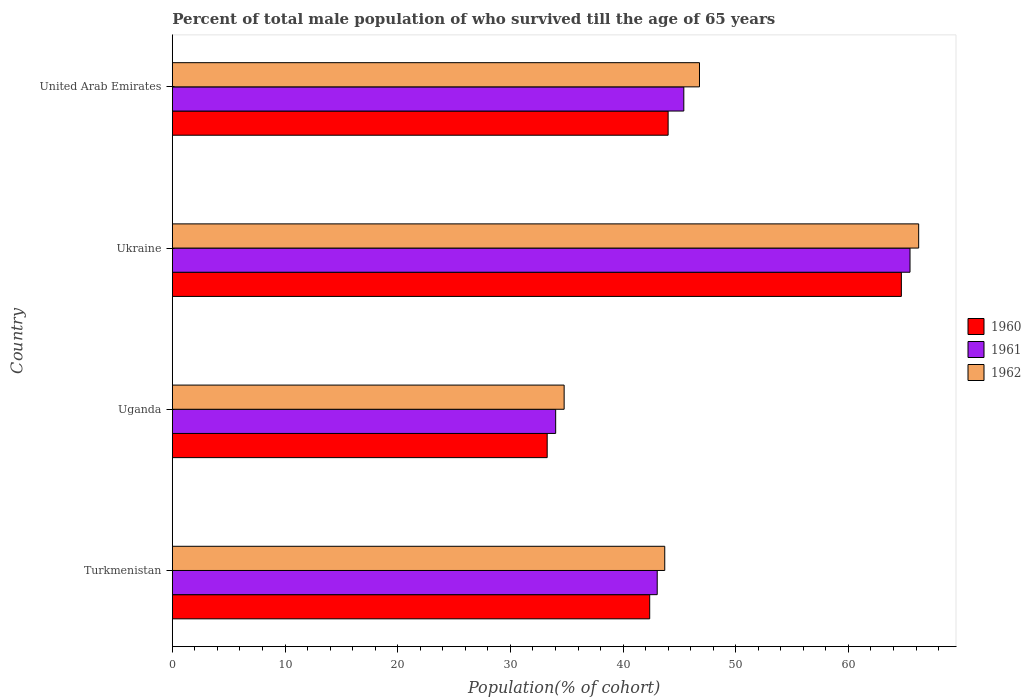How many bars are there on the 4th tick from the top?
Your response must be concise. 3. How many bars are there on the 3rd tick from the bottom?
Give a very brief answer. 3. What is the label of the 4th group of bars from the top?
Offer a very short reply. Turkmenistan. What is the percentage of total male population who survived till the age of 65 years in 1960 in Uganda?
Ensure brevity in your answer.  33.27. Across all countries, what is the maximum percentage of total male population who survived till the age of 65 years in 1960?
Make the answer very short. 64.7. Across all countries, what is the minimum percentage of total male population who survived till the age of 65 years in 1962?
Give a very brief answer. 34.77. In which country was the percentage of total male population who survived till the age of 65 years in 1960 maximum?
Ensure brevity in your answer.  Ukraine. In which country was the percentage of total male population who survived till the age of 65 years in 1961 minimum?
Your response must be concise. Uganda. What is the total percentage of total male population who survived till the age of 65 years in 1961 in the graph?
Offer a terse response. 187.9. What is the difference between the percentage of total male population who survived till the age of 65 years in 1962 in Uganda and that in Ukraine?
Your answer should be compact. -31.46. What is the difference between the percentage of total male population who survived till the age of 65 years in 1962 in Uganda and the percentage of total male population who survived till the age of 65 years in 1961 in United Arab Emirates?
Ensure brevity in your answer.  -10.62. What is the average percentage of total male population who survived till the age of 65 years in 1961 per country?
Provide a short and direct response. 46.98. What is the difference between the percentage of total male population who survived till the age of 65 years in 1960 and percentage of total male population who survived till the age of 65 years in 1961 in Ukraine?
Ensure brevity in your answer.  -0.77. What is the ratio of the percentage of total male population who survived till the age of 65 years in 1960 in Turkmenistan to that in United Arab Emirates?
Your response must be concise. 0.96. Is the percentage of total male population who survived till the age of 65 years in 1962 in Turkmenistan less than that in Ukraine?
Your answer should be very brief. Yes. What is the difference between the highest and the second highest percentage of total male population who survived till the age of 65 years in 1962?
Keep it short and to the point. 19.45. What is the difference between the highest and the lowest percentage of total male population who survived till the age of 65 years in 1962?
Offer a very short reply. 31.46. What does the 2nd bar from the top in United Arab Emirates represents?
Give a very brief answer. 1961. Is it the case that in every country, the sum of the percentage of total male population who survived till the age of 65 years in 1962 and percentage of total male population who survived till the age of 65 years in 1961 is greater than the percentage of total male population who survived till the age of 65 years in 1960?
Make the answer very short. Yes. How many bars are there?
Offer a terse response. 12. Are the values on the major ticks of X-axis written in scientific E-notation?
Your response must be concise. No. Where does the legend appear in the graph?
Provide a short and direct response. Center right. What is the title of the graph?
Make the answer very short. Percent of total male population of who survived till the age of 65 years. What is the label or title of the X-axis?
Keep it short and to the point. Population(% of cohort). What is the Population(% of cohort) of 1960 in Turkmenistan?
Provide a short and direct response. 42.36. What is the Population(% of cohort) in 1961 in Turkmenistan?
Your response must be concise. 43.03. What is the Population(% of cohort) in 1962 in Turkmenistan?
Provide a succinct answer. 43.7. What is the Population(% of cohort) of 1960 in Uganda?
Keep it short and to the point. 33.27. What is the Population(% of cohort) in 1961 in Uganda?
Your answer should be compact. 34.02. What is the Population(% of cohort) of 1962 in Uganda?
Your answer should be very brief. 34.77. What is the Population(% of cohort) in 1960 in Ukraine?
Your answer should be very brief. 64.7. What is the Population(% of cohort) in 1961 in Ukraine?
Give a very brief answer. 65.46. What is the Population(% of cohort) in 1962 in Ukraine?
Keep it short and to the point. 66.23. What is the Population(% of cohort) of 1960 in United Arab Emirates?
Offer a very short reply. 44. What is the Population(% of cohort) in 1961 in United Arab Emirates?
Ensure brevity in your answer.  45.39. What is the Population(% of cohort) of 1962 in United Arab Emirates?
Keep it short and to the point. 46.78. Across all countries, what is the maximum Population(% of cohort) in 1960?
Ensure brevity in your answer.  64.7. Across all countries, what is the maximum Population(% of cohort) in 1961?
Provide a succinct answer. 65.46. Across all countries, what is the maximum Population(% of cohort) in 1962?
Provide a short and direct response. 66.23. Across all countries, what is the minimum Population(% of cohort) in 1960?
Give a very brief answer. 33.27. Across all countries, what is the minimum Population(% of cohort) of 1961?
Offer a terse response. 34.02. Across all countries, what is the minimum Population(% of cohort) in 1962?
Offer a very short reply. 34.77. What is the total Population(% of cohort) of 1960 in the graph?
Ensure brevity in your answer.  184.32. What is the total Population(% of cohort) in 1961 in the graph?
Provide a succinct answer. 187.9. What is the total Population(% of cohort) in 1962 in the graph?
Ensure brevity in your answer.  191.48. What is the difference between the Population(% of cohort) of 1960 in Turkmenistan and that in Uganda?
Make the answer very short. 9.1. What is the difference between the Population(% of cohort) of 1961 in Turkmenistan and that in Uganda?
Provide a short and direct response. 9.01. What is the difference between the Population(% of cohort) of 1962 in Turkmenistan and that in Uganda?
Keep it short and to the point. 8.93. What is the difference between the Population(% of cohort) in 1960 in Turkmenistan and that in Ukraine?
Keep it short and to the point. -22.33. What is the difference between the Population(% of cohort) in 1961 in Turkmenistan and that in Ukraine?
Your answer should be very brief. -22.43. What is the difference between the Population(% of cohort) in 1962 in Turkmenistan and that in Ukraine?
Your response must be concise. -22.54. What is the difference between the Population(% of cohort) of 1960 in Turkmenistan and that in United Arab Emirates?
Offer a very short reply. -1.64. What is the difference between the Population(% of cohort) in 1961 in Turkmenistan and that in United Arab Emirates?
Ensure brevity in your answer.  -2.36. What is the difference between the Population(% of cohort) in 1962 in Turkmenistan and that in United Arab Emirates?
Provide a short and direct response. -3.08. What is the difference between the Population(% of cohort) in 1960 in Uganda and that in Ukraine?
Provide a short and direct response. -31.43. What is the difference between the Population(% of cohort) of 1961 in Uganda and that in Ukraine?
Your answer should be compact. -31.45. What is the difference between the Population(% of cohort) of 1962 in Uganda and that in Ukraine?
Your answer should be very brief. -31.46. What is the difference between the Population(% of cohort) in 1960 in Uganda and that in United Arab Emirates?
Your answer should be compact. -10.73. What is the difference between the Population(% of cohort) of 1961 in Uganda and that in United Arab Emirates?
Offer a very short reply. -11.37. What is the difference between the Population(% of cohort) of 1962 in Uganda and that in United Arab Emirates?
Give a very brief answer. -12.01. What is the difference between the Population(% of cohort) of 1960 in Ukraine and that in United Arab Emirates?
Your answer should be compact. 20.7. What is the difference between the Population(% of cohort) of 1961 in Ukraine and that in United Arab Emirates?
Ensure brevity in your answer.  20.07. What is the difference between the Population(% of cohort) in 1962 in Ukraine and that in United Arab Emirates?
Provide a short and direct response. 19.45. What is the difference between the Population(% of cohort) in 1960 in Turkmenistan and the Population(% of cohort) in 1961 in Uganda?
Your response must be concise. 8.35. What is the difference between the Population(% of cohort) in 1960 in Turkmenistan and the Population(% of cohort) in 1962 in Uganda?
Offer a terse response. 7.59. What is the difference between the Population(% of cohort) in 1961 in Turkmenistan and the Population(% of cohort) in 1962 in Uganda?
Your response must be concise. 8.26. What is the difference between the Population(% of cohort) in 1960 in Turkmenistan and the Population(% of cohort) in 1961 in Ukraine?
Make the answer very short. -23.1. What is the difference between the Population(% of cohort) of 1960 in Turkmenistan and the Population(% of cohort) of 1962 in Ukraine?
Give a very brief answer. -23.87. What is the difference between the Population(% of cohort) in 1961 in Turkmenistan and the Population(% of cohort) in 1962 in Ukraine?
Your response must be concise. -23.2. What is the difference between the Population(% of cohort) of 1960 in Turkmenistan and the Population(% of cohort) of 1961 in United Arab Emirates?
Keep it short and to the point. -3.03. What is the difference between the Population(% of cohort) of 1960 in Turkmenistan and the Population(% of cohort) of 1962 in United Arab Emirates?
Give a very brief answer. -4.42. What is the difference between the Population(% of cohort) in 1961 in Turkmenistan and the Population(% of cohort) in 1962 in United Arab Emirates?
Provide a short and direct response. -3.75. What is the difference between the Population(% of cohort) of 1960 in Uganda and the Population(% of cohort) of 1961 in Ukraine?
Your answer should be very brief. -32.2. What is the difference between the Population(% of cohort) in 1960 in Uganda and the Population(% of cohort) in 1962 in Ukraine?
Provide a succinct answer. -32.97. What is the difference between the Population(% of cohort) in 1961 in Uganda and the Population(% of cohort) in 1962 in Ukraine?
Your answer should be compact. -32.22. What is the difference between the Population(% of cohort) in 1960 in Uganda and the Population(% of cohort) in 1961 in United Arab Emirates?
Your answer should be very brief. -12.12. What is the difference between the Population(% of cohort) in 1960 in Uganda and the Population(% of cohort) in 1962 in United Arab Emirates?
Provide a succinct answer. -13.52. What is the difference between the Population(% of cohort) in 1961 in Uganda and the Population(% of cohort) in 1962 in United Arab Emirates?
Your response must be concise. -12.76. What is the difference between the Population(% of cohort) of 1960 in Ukraine and the Population(% of cohort) of 1961 in United Arab Emirates?
Keep it short and to the point. 19.31. What is the difference between the Population(% of cohort) in 1960 in Ukraine and the Population(% of cohort) in 1962 in United Arab Emirates?
Your response must be concise. 17.91. What is the difference between the Population(% of cohort) of 1961 in Ukraine and the Population(% of cohort) of 1962 in United Arab Emirates?
Ensure brevity in your answer.  18.68. What is the average Population(% of cohort) in 1960 per country?
Your answer should be very brief. 46.08. What is the average Population(% of cohort) in 1961 per country?
Provide a short and direct response. 46.98. What is the average Population(% of cohort) of 1962 per country?
Provide a short and direct response. 47.87. What is the difference between the Population(% of cohort) of 1960 and Population(% of cohort) of 1961 in Turkmenistan?
Your answer should be very brief. -0.67. What is the difference between the Population(% of cohort) of 1960 and Population(% of cohort) of 1962 in Turkmenistan?
Offer a terse response. -1.34. What is the difference between the Population(% of cohort) in 1961 and Population(% of cohort) in 1962 in Turkmenistan?
Your answer should be compact. -0.67. What is the difference between the Population(% of cohort) of 1960 and Population(% of cohort) of 1961 in Uganda?
Your answer should be compact. -0.75. What is the difference between the Population(% of cohort) of 1960 and Population(% of cohort) of 1962 in Uganda?
Make the answer very short. -1.5. What is the difference between the Population(% of cohort) of 1961 and Population(% of cohort) of 1962 in Uganda?
Your answer should be very brief. -0.75. What is the difference between the Population(% of cohort) in 1960 and Population(% of cohort) in 1961 in Ukraine?
Keep it short and to the point. -0.77. What is the difference between the Population(% of cohort) of 1960 and Population(% of cohort) of 1962 in Ukraine?
Provide a short and direct response. -1.54. What is the difference between the Population(% of cohort) in 1961 and Population(% of cohort) in 1962 in Ukraine?
Keep it short and to the point. -0.77. What is the difference between the Population(% of cohort) in 1960 and Population(% of cohort) in 1961 in United Arab Emirates?
Your response must be concise. -1.39. What is the difference between the Population(% of cohort) of 1960 and Population(% of cohort) of 1962 in United Arab Emirates?
Provide a short and direct response. -2.78. What is the difference between the Population(% of cohort) in 1961 and Population(% of cohort) in 1962 in United Arab Emirates?
Ensure brevity in your answer.  -1.39. What is the ratio of the Population(% of cohort) in 1960 in Turkmenistan to that in Uganda?
Give a very brief answer. 1.27. What is the ratio of the Population(% of cohort) in 1961 in Turkmenistan to that in Uganda?
Offer a terse response. 1.26. What is the ratio of the Population(% of cohort) in 1962 in Turkmenistan to that in Uganda?
Provide a succinct answer. 1.26. What is the ratio of the Population(% of cohort) in 1960 in Turkmenistan to that in Ukraine?
Offer a terse response. 0.65. What is the ratio of the Population(% of cohort) in 1961 in Turkmenistan to that in Ukraine?
Your answer should be very brief. 0.66. What is the ratio of the Population(% of cohort) in 1962 in Turkmenistan to that in Ukraine?
Your answer should be very brief. 0.66. What is the ratio of the Population(% of cohort) in 1960 in Turkmenistan to that in United Arab Emirates?
Provide a short and direct response. 0.96. What is the ratio of the Population(% of cohort) of 1961 in Turkmenistan to that in United Arab Emirates?
Make the answer very short. 0.95. What is the ratio of the Population(% of cohort) in 1962 in Turkmenistan to that in United Arab Emirates?
Your answer should be compact. 0.93. What is the ratio of the Population(% of cohort) in 1960 in Uganda to that in Ukraine?
Ensure brevity in your answer.  0.51. What is the ratio of the Population(% of cohort) of 1961 in Uganda to that in Ukraine?
Provide a succinct answer. 0.52. What is the ratio of the Population(% of cohort) of 1962 in Uganda to that in Ukraine?
Offer a very short reply. 0.53. What is the ratio of the Population(% of cohort) in 1960 in Uganda to that in United Arab Emirates?
Give a very brief answer. 0.76. What is the ratio of the Population(% of cohort) of 1961 in Uganda to that in United Arab Emirates?
Offer a terse response. 0.75. What is the ratio of the Population(% of cohort) of 1962 in Uganda to that in United Arab Emirates?
Offer a terse response. 0.74. What is the ratio of the Population(% of cohort) in 1960 in Ukraine to that in United Arab Emirates?
Offer a very short reply. 1.47. What is the ratio of the Population(% of cohort) of 1961 in Ukraine to that in United Arab Emirates?
Your answer should be very brief. 1.44. What is the ratio of the Population(% of cohort) in 1962 in Ukraine to that in United Arab Emirates?
Provide a short and direct response. 1.42. What is the difference between the highest and the second highest Population(% of cohort) in 1960?
Provide a succinct answer. 20.7. What is the difference between the highest and the second highest Population(% of cohort) of 1961?
Ensure brevity in your answer.  20.07. What is the difference between the highest and the second highest Population(% of cohort) of 1962?
Give a very brief answer. 19.45. What is the difference between the highest and the lowest Population(% of cohort) in 1960?
Give a very brief answer. 31.43. What is the difference between the highest and the lowest Population(% of cohort) of 1961?
Keep it short and to the point. 31.45. What is the difference between the highest and the lowest Population(% of cohort) of 1962?
Your answer should be very brief. 31.46. 